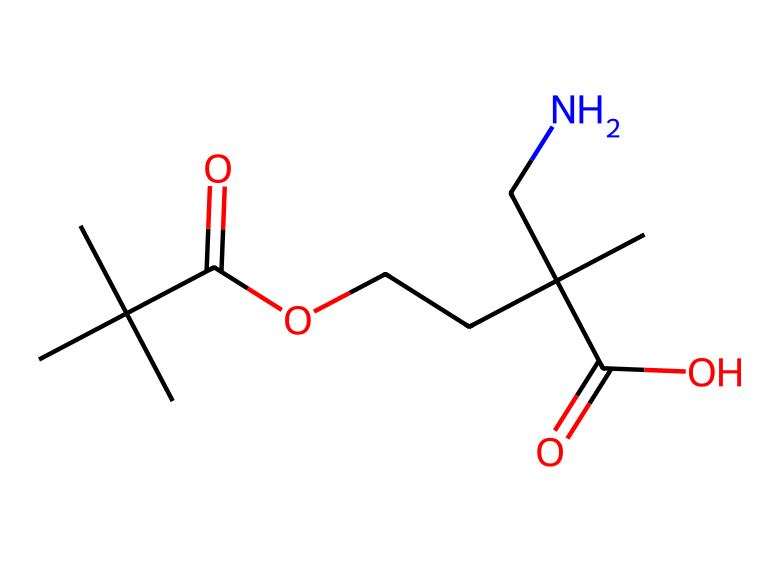What is the overall molecular formula derived from the SMILES representation? The SMILES indicates the number and types of atoms present. By analyzing the structure, we can count the carbons, hydrogens, oxygens, and nitrogens. For this compound, there are 12 carbon atoms, 23 hydrogen atoms, 4 oxygen atoms, and 1 nitrogen atom, leading to a molecular formula of C12H23N4O4.
Answer: C12H23N4O4 How many functional groups are present in this chemical? Looking at the SMILES representation, we can identify carboxylic groups (–COOH) and amine groups (–NH2) as functional groups. The compound has two carboxylic groups and one amine group, totaling three functional groups.
Answer: 3 Which type of polymer does this chemical represent? The presence of ester linkages indicates that this compound forms part of acrylic polymers, typically derived from acrylic acids. This structure specifically suggests it belongs to polyacrylic fibers.
Answer: acrylic polymer What is the significance of the nitrogen atom in this structure? The nitrogen atom signifies the presence of an amine group, which can affect the polymer's solubility and interaction with water. This property can influence how the fibers behave in modeling clay, making them more pliable and easier to manipulate.
Answer: amine group What kind of intermolecular forces might be observed in fibers made from this structure? The presence of polar functional groups, such as –COOH and –NH2, suggests that hydrogen bonding can occur between molecules. This can enhance the tensile strength and thermal properties of the fibers.
Answer: hydrogen bonds How does the branching in the carbon chain affect the properties of the fibers? The branched carbon structure can influence the packing efficiency of the polymer chains. A branched structure typically results in lower density and may provide enhanced flexibility and reduced brittleness in the fibers compared to linear polymers.
Answer: flexibility 